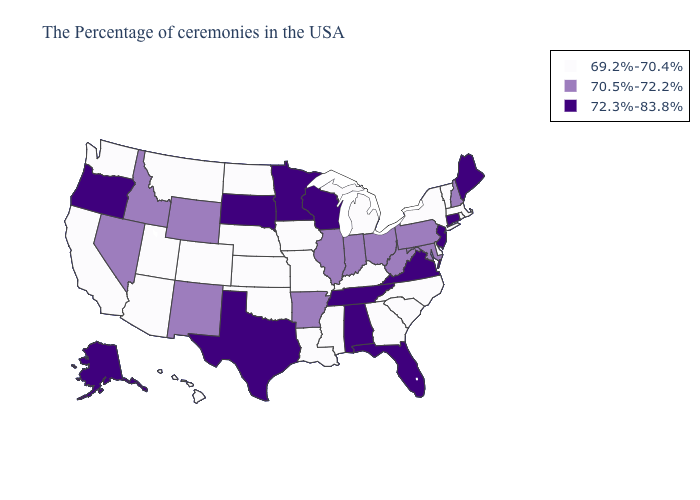What is the highest value in the USA?
Short answer required. 72.3%-83.8%. Name the states that have a value in the range 69.2%-70.4%?
Concise answer only. Massachusetts, Rhode Island, Vermont, New York, Delaware, North Carolina, South Carolina, Georgia, Michigan, Kentucky, Mississippi, Louisiana, Missouri, Iowa, Kansas, Nebraska, Oklahoma, North Dakota, Colorado, Utah, Montana, Arizona, California, Washington, Hawaii. Name the states that have a value in the range 70.5%-72.2%?
Answer briefly. New Hampshire, Maryland, Pennsylvania, West Virginia, Ohio, Indiana, Illinois, Arkansas, Wyoming, New Mexico, Idaho, Nevada. What is the value of Wyoming?
Concise answer only. 70.5%-72.2%. What is the lowest value in states that border Louisiana?
Keep it brief. 69.2%-70.4%. What is the value of Alaska?
Keep it brief. 72.3%-83.8%. How many symbols are there in the legend?
Short answer required. 3. Name the states that have a value in the range 69.2%-70.4%?
Write a very short answer. Massachusetts, Rhode Island, Vermont, New York, Delaware, North Carolina, South Carolina, Georgia, Michigan, Kentucky, Mississippi, Louisiana, Missouri, Iowa, Kansas, Nebraska, Oklahoma, North Dakota, Colorado, Utah, Montana, Arizona, California, Washington, Hawaii. Does Maine have the lowest value in the Northeast?
Write a very short answer. No. Among the states that border Virginia , does Tennessee have the highest value?
Keep it brief. Yes. Name the states that have a value in the range 72.3%-83.8%?
Concise answer only. Maine, Connecticut, New Jersey, Virginia, Florida, Alabama, Tennessee, Wisconsin, Minnesota, Texas, South Dakota, Oregon, Alaska. Among the states that border Kansas , which have the lowest value?
Concise answer only. Missouri, Nebraska, Oklahoma, Colorado. What is the lowest value in the USA?
Quick response, please. 69.2%-70.4%. Does Kentucky have the same value as New Jersey?
Write a very short answer. No. What is the value of Kansas?
Keep it brief. 69.2%-70.4%. 